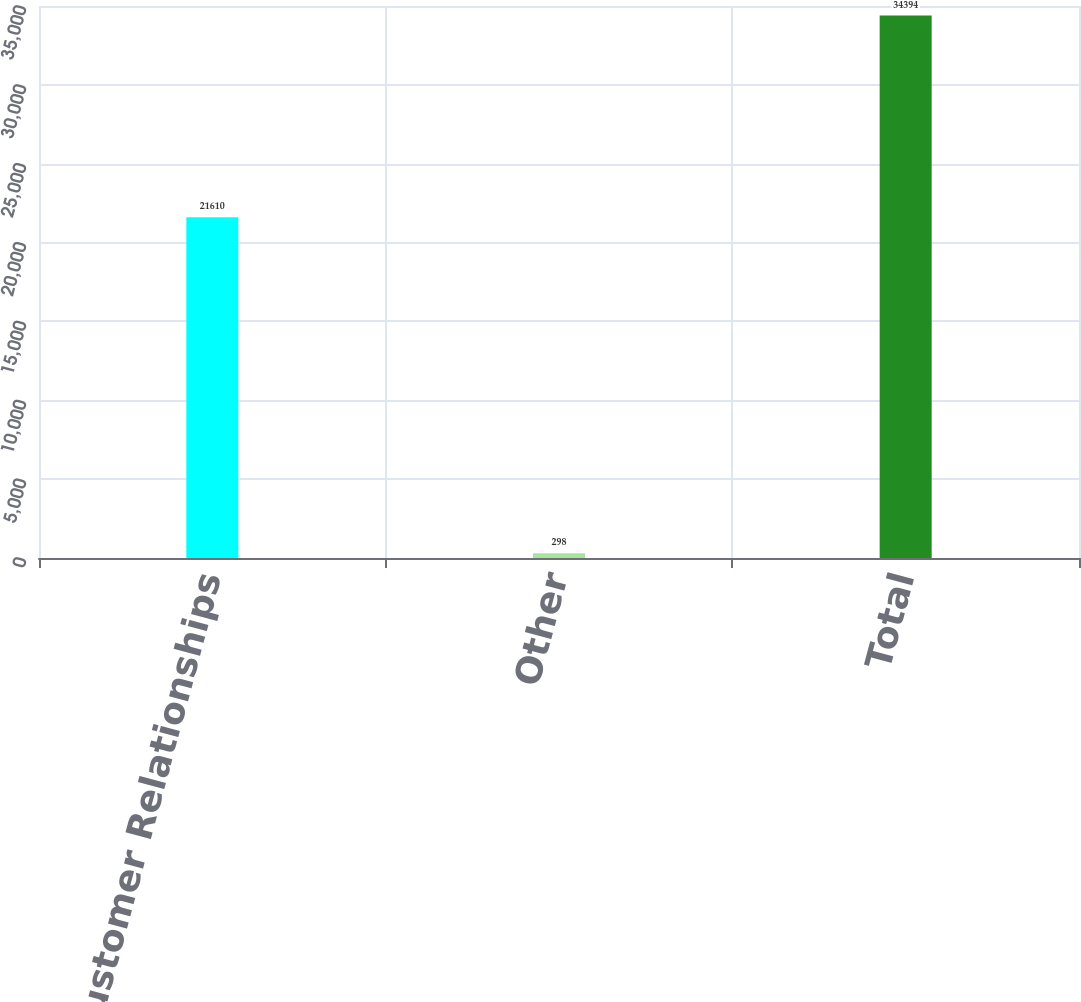Convert chart to OTSL. <chart><loc_0><loc_0><loc_500><loc_500><bar_chart><fcel>Customer Relationships<fcel>Other<fcel>Total<nl><fcel>21610<fcel>298<fcel>34394<nl></chart> 